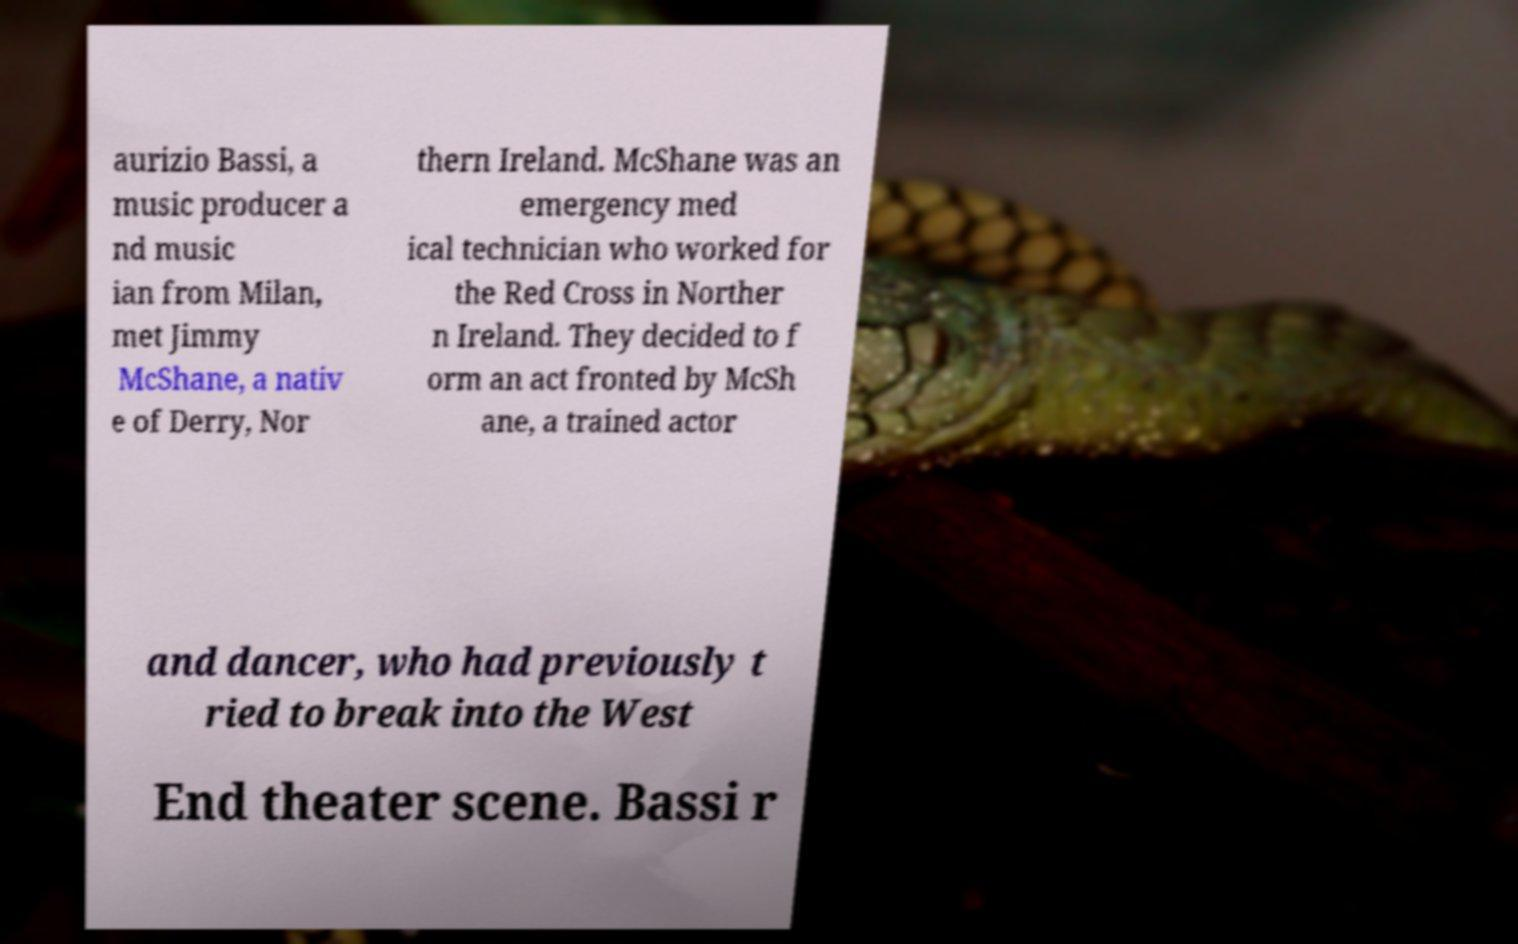I need the written content from this picture converted into text. Can you do that? aurizio Bassi, a music producer a nd music ian from Milan, met Jimmy McShane, a nativ e of Derry, Nor thern Ireland. McShane was an emergency med ical technician who worked for the Red Cross in Norther n Ireland. They decided to f orm an act fronted by McSh ane, a trained actor and dancer, who had previously t ried to break into the West End theater scene. Bassi r 